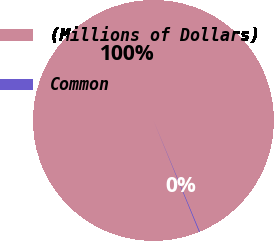Convert chart. <chart><loc_0><loc_0><loc_500><loc_500><pie_chart><fcel>(Millions of Dollars)<fcel>Common<nl><fcel>99.9%<fcel>0.1%<nl></chart> 